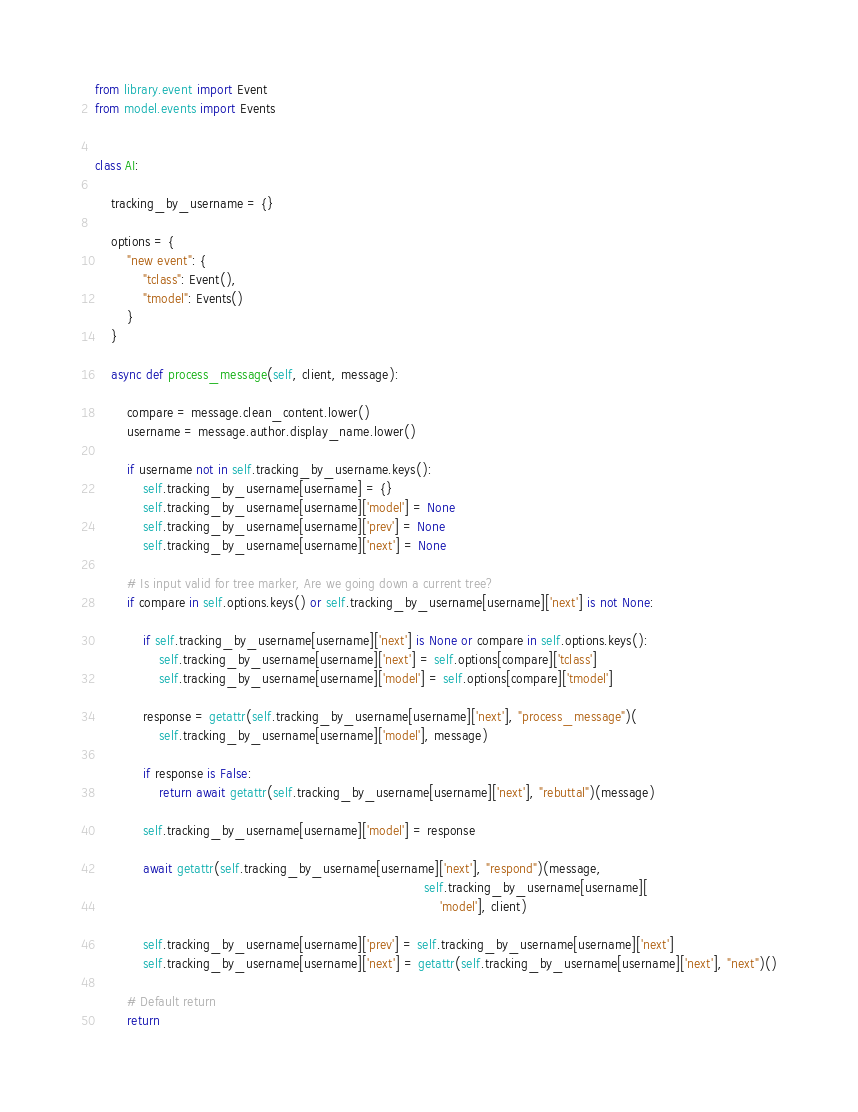Convert code to text. <code><loc_0><loc_0><loc_500><loc_500><_Python_>from library.event import Event
from model.events import Events


class AI:

    tracking_by_username = {}

    options = {
        "new event": {
            "tclass": Event(),
            "tmodel": Events()
        }
    }

    async def process_message(self, client, message):

        compare = message.clean_content.lower()
        username = message.author.display_name.lower()

        if username not in self.tracking_by_username.keys():
            self.tracking_by_username[username] = {}
            self.tracking_by_username[username]['model'] = None
            self.tracking_by_username[username]['prev'] = None
            self.tracking_by_username[username]['next'] = None

        # Is input valid for tree marker, Are we going down a current tree?
        if compare in self.options.keys() or self.tracking_by_username[username]['next'] is not None:

            if self.tracking_by_username[username]['next'] is None or compare in self.options.keys():
                self.tracking_by_username[username]['next'] = self.options[compare]['tclass']
                self.tracking_by_username[username]['model'] = self.options[compare]['tmodel']

            response = getattr(self.tracking_by_username[username]['next'], "process_message")(
                self.tracking_by_username[username]['model'], message)

            if response is False:
                return await getattr(self.tracking_by_username[username]['next'], "rebuttal")(message)

            self.tracking_by_username[username]['model'] = response

            await getattr(self.tracking_by_username[username]['next'], "respond")(message,
                                                                                  self.tracking_by_username[username][
                                                                                      'model'], client)

            self.tracking_by_username[username]['prev'] = self.tracking_by_username[username]['next']
            self.tracking_by_username[username]['next'] = getattr(self.tracking_by_username[username]['next'], "next")()

        # Default return
        return
</code> 